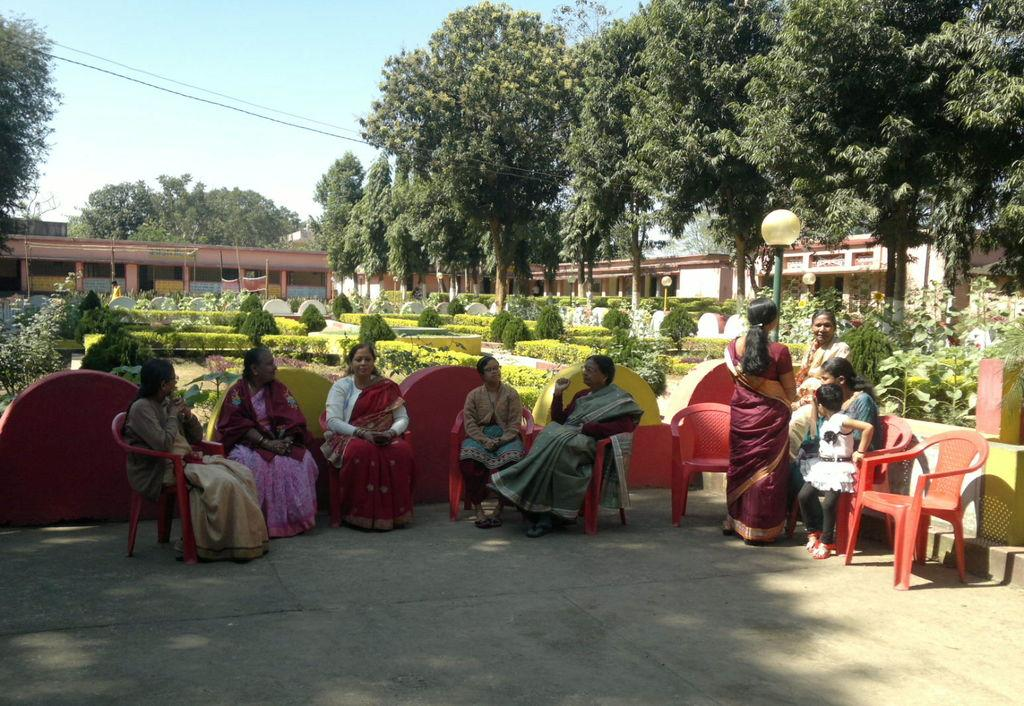Where was the image taken? The image is taken outdoors. What is the weather like in the image? It is sunny in the image. What are the people in the image doing? There is a group of people sitting on chairs. What can be seen behind the people? There is a pole, bushes, a building, and a tree behind the people. What part of the natural environment is visible in the image? The sky is visible in the image. What type of glue is being used by the people in the image? There is no glue present in the image, and therefore no such activity can be observed. What are the people in the image writing on? There is no writing activity depicted in the image; the people are sitting on chairs. 